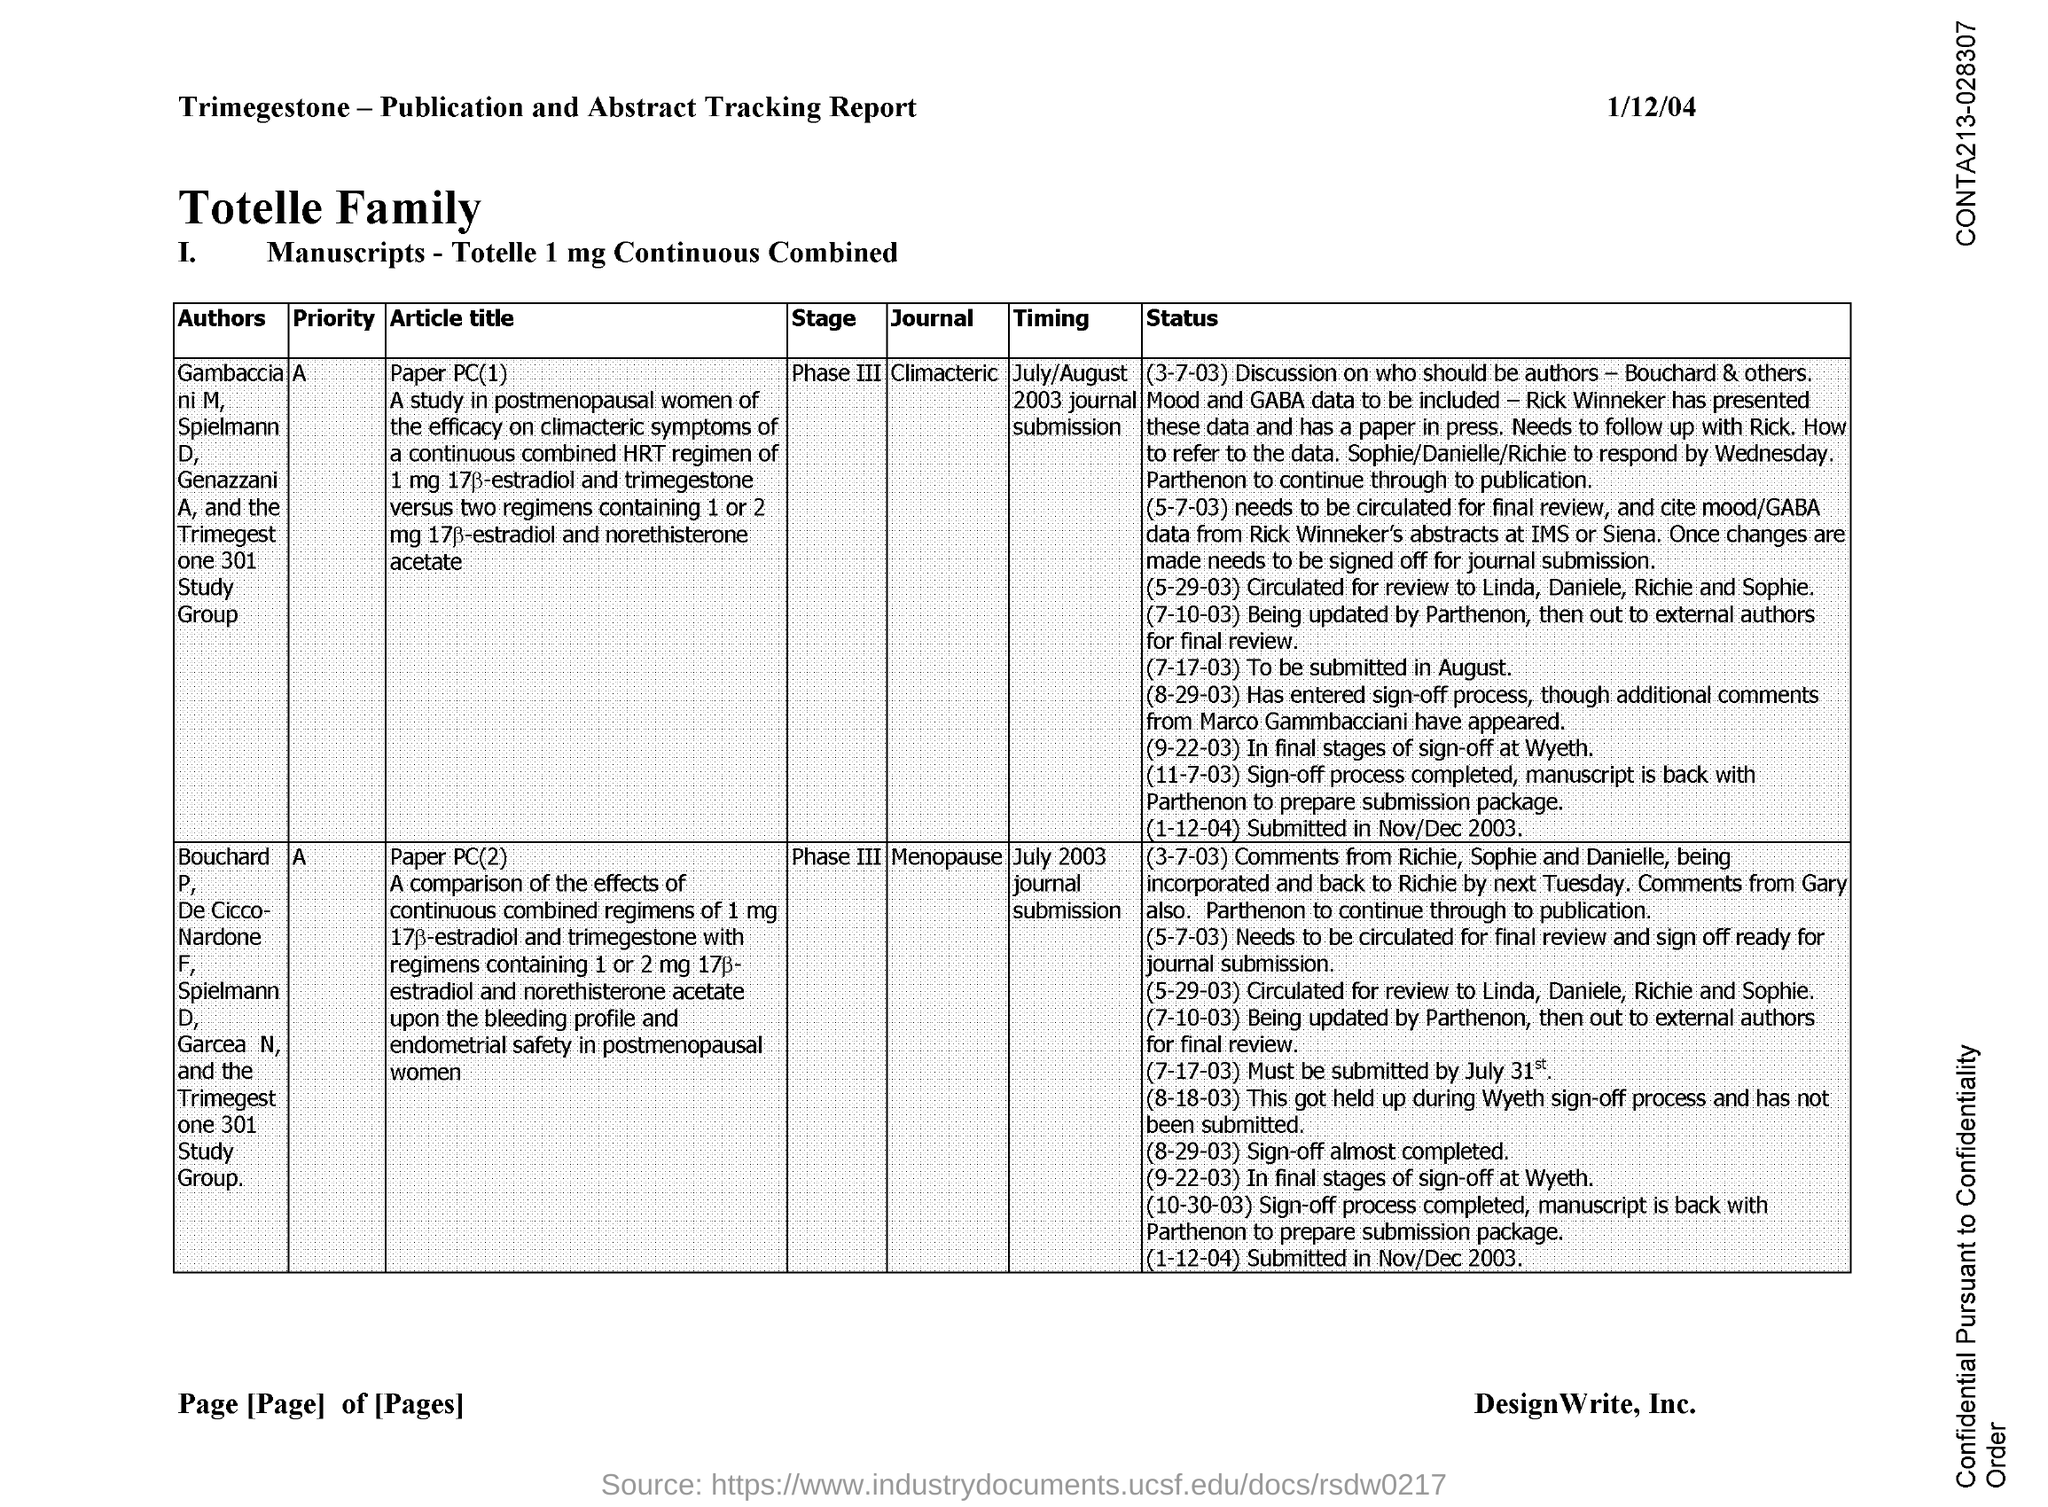Draw attention to some important aspects in this diagram. The date on the document is January 12, 2004. 